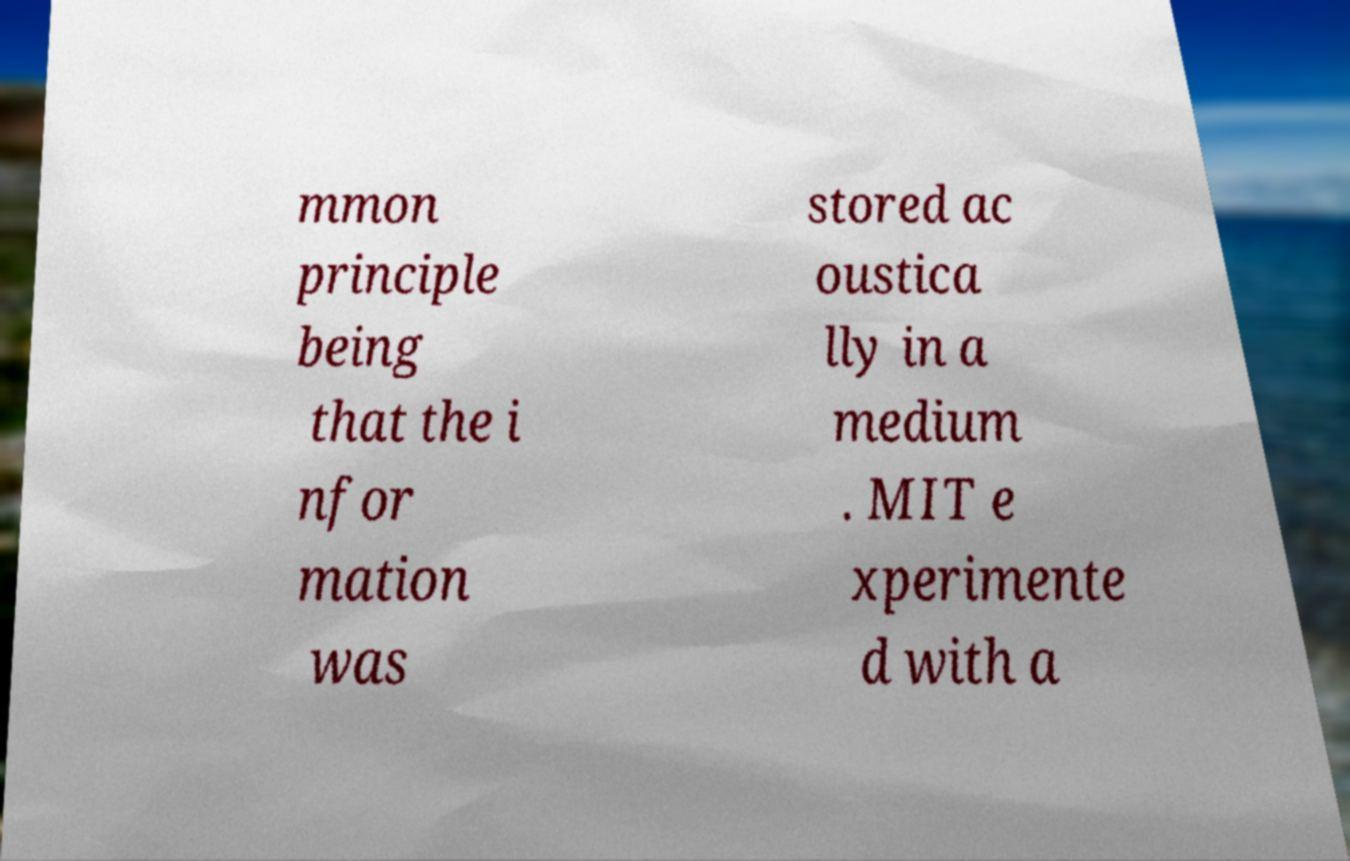There's text embedded in this image that I need extracted. Can you transcribe it verbatim? mmon principle being that the i nfor mation was stored ac oustica lly in a medium . MIT e xperimente d with a 